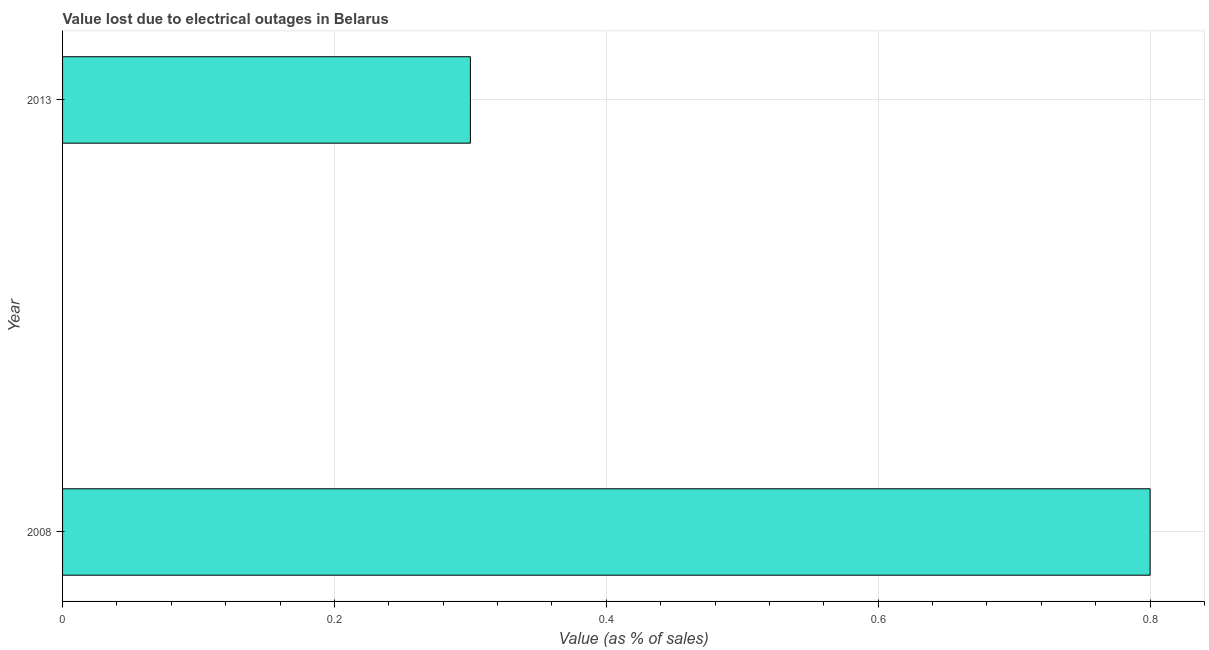Does the graph contain any zero values?
Your response must be concise. No. What is the title of the graph?
Your response must be concise. Value lost due to electrical outages in Belarus. What is the label or title of the X-axis?
Give a very brief answer. Value (as % of sales). In which year was the value lost due to electrical outages maximum?
Give a very brief answer. 2008. What is the sum of the value lost due to electrical outages?
Make the answer very short. 1.1. What is the difference between the value lost due to electrical outages in 2008 and 2013?
Provide a succinct answer. 0.5. What is the average value lost due to electrical outages per year?
Keep it short and to the point. 0.55. What is the median value lost due to electrical outages?
Offer a very short reply. 0.55. Do a majority of the years between 2008 and 2013 (inclusive) have value lost due to electrical outages greater than 0.36 %?
Offer a terse response. No. What is the ratio of the value lost due to electrical outages in 2008 to that in 2013?
Provide a succinct answer. 2.67. Is the value lost due to electrical outages in 2008 less than that in 2013?
Your answer should be compact. No. How many bars are there?
Your answer should be compact. 2. Are all the bars in the graph horizontal?
Your response must be concise. Yes. How many years are there in the graph?
Make the answer very short. 2. What is the difference between two consecutive major ticks on the X-axis?
Ensure brevity in your answer.  0.2. Are the values on the major ticks of X-axis written in scientific E-notation?
Provide a short and direct response. No. What is the difference between the Value (as % of sales) in 2008 and 2013?
Keep it short and to the point. 0.5. What is the ratio of the Value (as % of sales) in 2008 to that in 2013?
Offer a very short reply. 2.67. 